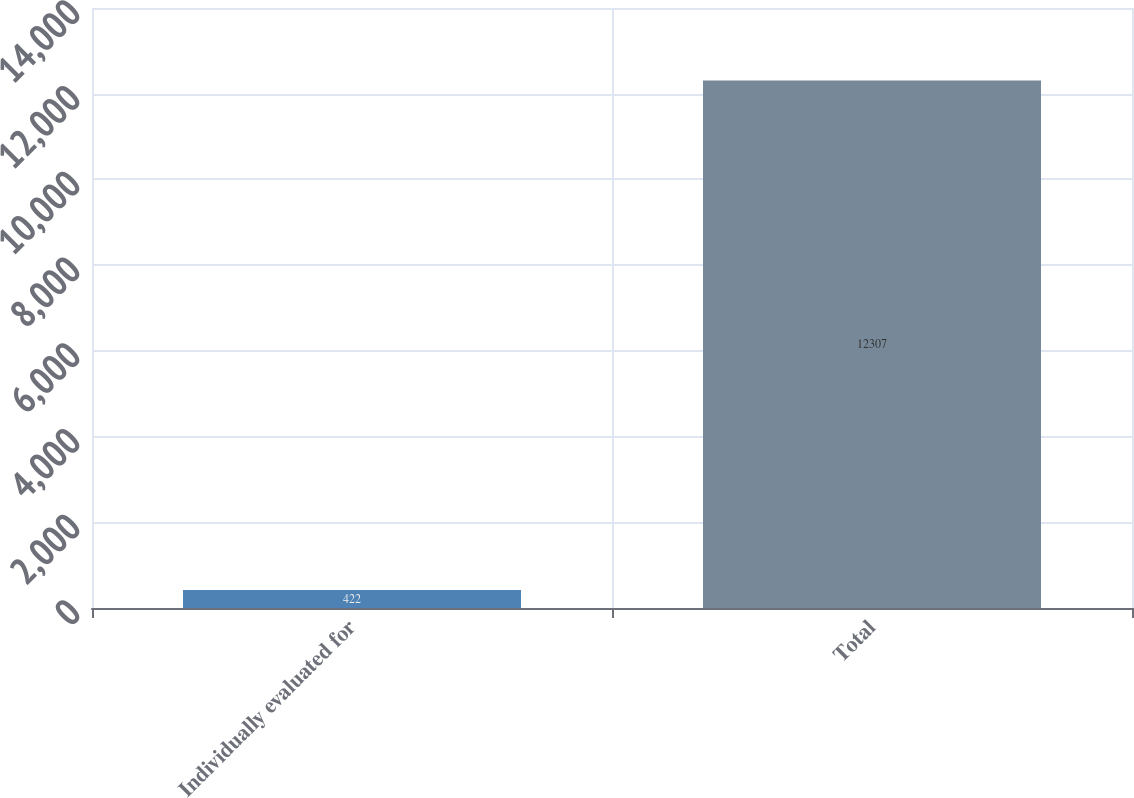Convert chart. <chart><loc_0><loc_0><loc_500><loc_500><bar_chart><fcel>Individually evaluated for<fcel>Total<nl><fcel>422<fcel>12307<nl></chart> 